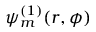Convert formula to latex. <formula><loc_0><loc_0><loc_500><loc_500>\psi _ { m } ^ { ( 1 ) } ( r , \phi )</formula> 